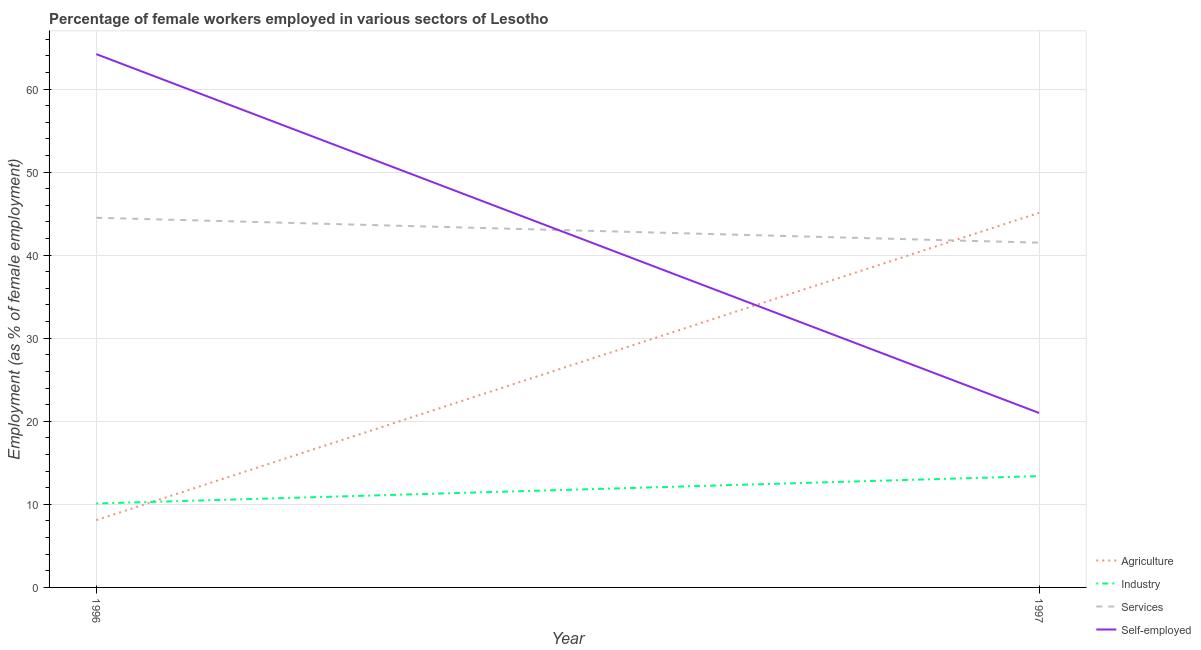Does the line corresponding to percentage of female workers in services intersect with the line corresponding to percentage of female workers in industry?
Your answer should be compact. No. Is the number of lines equal to the number of legend labels?
Offer a terse response. Yes. What is the percentage of female workers in services in 1996?
Provide a short and direct response. 44.5. Across all years, what is the maximum percentage of self employed female workers?
Make the answer very short. 64.2. Across all years, what is the minimum percentage of female workers in industry?
Keep it short and to the point. 10.1. What is the total percentage of female workers in services in the graph?
Give a very brief answer. 86. What is the difference between the percentage of female workers in services in 1996 and that in 1997?
Provide a succinct answer. 3. What is the difference between the percentage of female workers in agriculture in 1997 and the percentage of female workers in services in 1996?
Keep it short and to the point. 0.6. What is the average percentage of female workers in industry per year?
Keep it short and to the point. 11.75. In the year 1996, what is the difference between the percentage of female workers in services and percentage of female workers in industry?
Your answer should be very brief. 34.4. What is the ratio of the percentage of female workers in services in 1996 to that in 1997?
Ensure brevity in your answer.  1.07. Is the percentage of self employed female workers in 1996 less than that in 1997?
Give a very brief answer. No. In how many years, is the percentage of female workers in agriculture greater than the average percentage of female workers in agriculture taken over all years?
Provide a succinct answer. 1. Is it the case that in every year, the sum of the percentage of female workers in industry and percentage of self employed female workers is greater than the sum of percentage of female workers in agriculture and percentage of female workers in services?
Provide a short and direct response. No. Is the percentage of female workers in industry strictly greater than the percentage of female workers in services over the years?
Give a very brief answer. No. How many lines are there?
Your answer should be very brief. 4. What is the difference between two consecutive major ticks on the Y-axis?
Keep it short and to the point. 10. Are the values on the major ticks of Y-axis written in scientific E-notation?
Provide a succinct answer. No. Does the graph contain any zero values?
Give a very brief answer. No. Does the graph contain grids?
Your answer should be very brief. Yes. What is the title of the graph?
Offer a terse response. Percentage of female workers employed in various sectors of Lesotho. Does "International Development Association" appear as one of the legend labels in the graph?
Your answer should be very brief. No. What is the label or title of the Y-axis?
Offer a very short reply. Employment (as % of female employment). What is the Employment (as % of female employment) in Agriculture in 1996?
Ensure brevity in your answer.  8.1. What is the Employment (as % of female employment) of Industry in 1996?
Ensure brevity in your answer.  10.1. What is the Employment (as % of female employment) in Services in 1996?
Give a very brief answer. 44.5. What is the Employment (as % of female employment) of Self-employed in 1996?
Provide a short and direct response. 64.2. What is the Employment (as % of female employment) in Agriculture in 1997?
Your answer should be compact. 45.1. What is the Employment (as % of female employment) of Industry in 1997?
Your answer should be compact. 13.4. What is the Employment (as % of female employment) in Services in 1997?
Your response must be concise. 41.5. Across all years, what is the maximum Employment (as % of female employment) of Agriculture?
Ensure brevity in your answer.  45.1. Across all years, what is the maximum Employment (as % of female employment) of Industry?
Give a very brief answer. 13.4. Across all years, what is the maximum Employment (as % of female employment) in Services?
Offer a very short reply. 44.5. Across all years, what is the maximum Employment (as % of female employment) of Self-employed?
Offer a very short reply. 64.2. Across all years, what is the minimum Employment (as % of female employment) of Agriculture?
Make the answer very short. 8.1. Across all years, what is the minimum Employment (as % of female employment) of Industry?
Give a very brief answer. 10.1. Across all years, what is the minimum Employment (as % of female employment) of Services?
Give a very brief answer. 41.5. What is the total Employment (as % of female employment) in Agriculture in the graph?
Offer a very short reply. 53.2. What is the total Employment (as % of female employment) in Self-employed in the graph?
Make the answer very short. 85.2. What is the difference between the Employment (as % of female employment) in Agriculture in 1996 and that in 1997?
Offer a terse response. -37. What is the difference between the Employment (as % of female employment) of Self-employed in 1996 and that in 1997?
Provide a short and direct response. 43.2. What is the difference between the Employment (as % of female employment) of Agriculture in 1996 and the Employment (as % of female employment) of Services in 1997?
Offer a very short reply. -33.4. What is the difference between the Employment (as % of female employment) of Agriculture in 1996 and the Employment (as % of female employment) of Self-employed in 1997?
Provide a succinct answer. -12.9. What is the difference between the Employment (as % of female employment) in Industry in 1996 and the Employment (as % of female employment) in Services in 1997?
Make the answer very short. -31.4. What is the difference between the Employment (as % of female employment) in Services in 1996 and the Employment (as % of female employment) in Self-employed in 1997?
Your response must be concise. 23.5. What is the average Employment (as % of female employment) of Agriculture per year?
Keep it short and to the point. 26.6. What is the average Employment (as % of female employment) of Industry per year?
Your response must be concise. 11.75. What is the average Employment (as % of female employment) of Self-employed per year?
Ensure brevity in your answer.  42.6. In the year 1996, what is the difference between the Employment (as % of female employment) of Agriculture and Employment (as % of female employment) of Services?
Offer a very short reply. -36.4. In the year 1996, what is the difference between the Employment (as % of female employment) of Agriculture and Employment (as % of female employment) of Self-employed?
Provide a short and direct response. -56.1. In the year 1996, what is the difference between the Employment (as % of female employment) of Industry and Employment (as % of female employment) of Services?
Your answer should be compact. -34.4. In the year 1996, what is the difference between the Employment (as % of female employment) in Industry and Employment (as % of female employment) in Self-employed?
Provide a succinct answer. -54.1. In the year 1996, what is the difference between the Employment (as % of female employment) of Services and Employment (as % of female employment) of Self-employed?
Offer a terse response. -19.7. In the year 1997, what is the difference between the Employment (as % of female employment) in Agriculture and Employment (as % of female employment) in Industry?
Your response must be concise. 31.7. In the year 1997, what is the difference between the Employment (as % of female employment) in Agriculture and Employment (as % of female employment) in Self-employed?
Your answer should be very brief. 24.1. In the year 1997, what is the difference between the Employment (as % of female employment) in Industry and Employment (as % of female employment) in Services?
Your response must be concise. -28.1. In the year 1997, what is the difference between the Employment (as % of female employment) of Industry and Employment (as % of female employment) of Self-employed?
Provide a succinct answer. -7.6. In the year 1997, what is the difference between the Employment (as % of female employment) of Services and Employment (as % of female employment) of Self-employed?
Ensure brevity in your answer.  20.5. What is the ratio of the Employment (as % of female employment) in Agriculture in 1996 to that in 1997?
Offer a very short reply. 0.18. What is the ratio of the Employment (as % of female employment) of Industry in 1996 to that in 1997?
Offer a terse response. 0.75. What is the ratio of the Employment (as % of female employment) of Services in 1996 to that in 1997?
Your answer should be compact. 1.07. What is the ratio of the Employment (as % of female employment) of Self-employed in 1996 to that in 1997?
Your response must be concise. 3.06. What is the difference between the highest and the second highest Employment (as % of female employment) of Agriculture?
Your response must be concise. 37. What is the difference between the highest and the second highest Employment (as % of female employment) in Self-employed?
Your answer should be compact. 43.2. What is the difference between the highest and the lowest Employment (as % of female employment) of Self-employed?
Offer a very short reply. 43.2. 